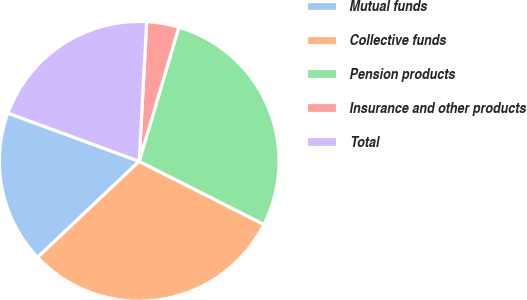Convert chart to OTSL. <chart><loc_0><loc_0><loc_500><loc_500><pie_chart><fcel>Mutual funds<fcel>Collective funds<fcel>Pension products<fcel>Insurance and other products<fcel>Total<nl><fcel>17.66%<fcel>30.48%<fcel>27.88%<fcel>3.72%<fcel>20.26%<nl></chart> 